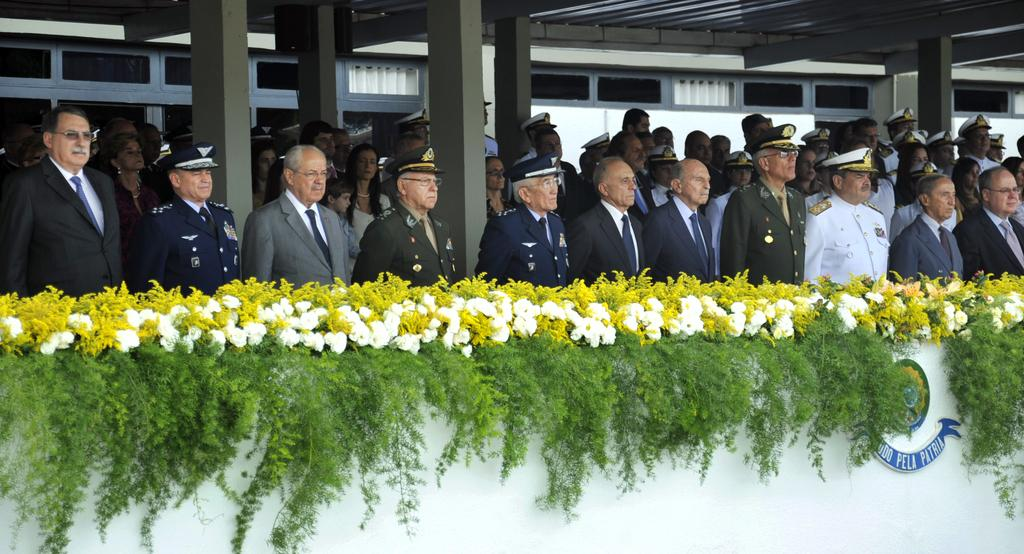What is the main subject of the image? The main subject of the image is a group of people. What are the people in the image doing? The people are standing. Can you describe any specific clothing or accessories worn by the people? Some people in the group are wearing caps. What else can be seen in the image besides the people? There are flowers visible in the image. What type of chain is being used to hold the stew in the image? There is no chain or stew present in the image; it features a group of people standing and flowers. 